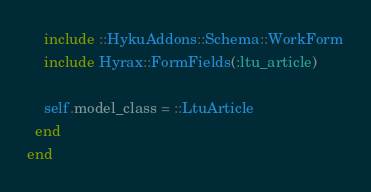Convert code to text. <code><loc_0><loc_0><loc_500><loc_500><_Ruby_>    include ::HykuAddons::Schema::WorkForm
    include Hyrax::FormFields(:ltu_article)

    self.model_class = ::LtuArticle
  end
end
</code> 